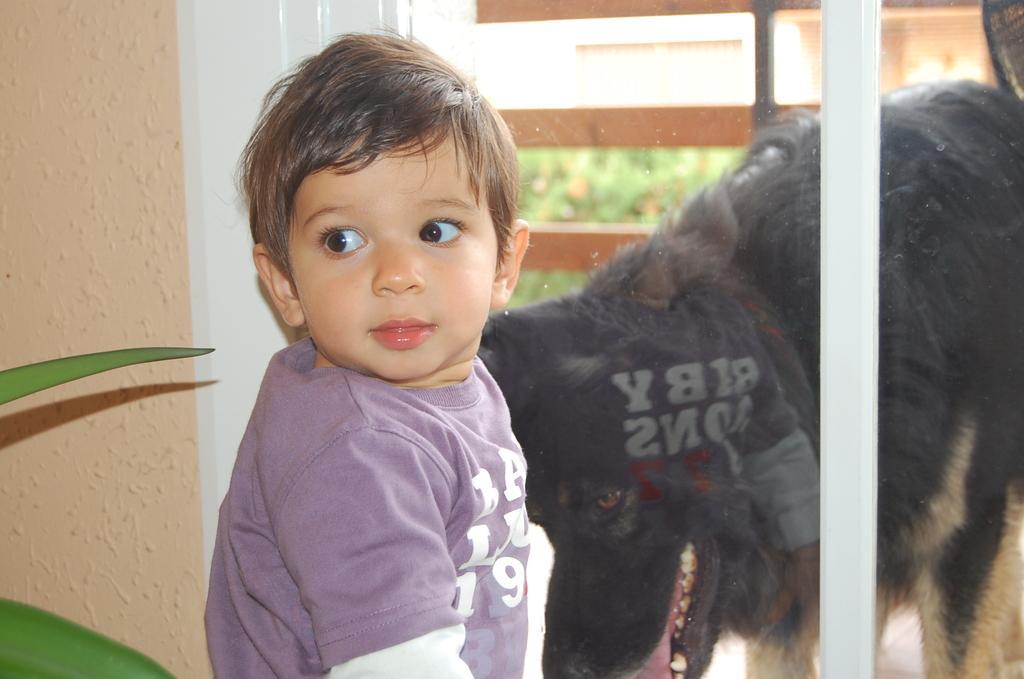Can you describe this image briefly? In this picture we can see a kid and a dog, beside to the kid we can find a plant, and also we can see glass. 